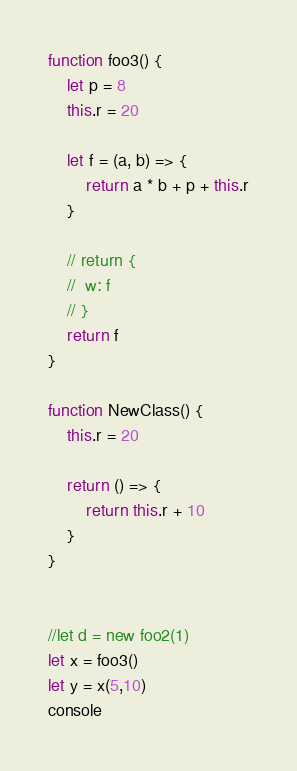<code> <loc_0><loc_0><loc_500><loc_500><_JavaScript_>function foo3() {
	let p = 8
	this.r = 20

	let f = (a, b) => {
		return a * b + p + this.r
	}

	// return {
	// 	w: f
	// }
	return f
}

function NewClass() {
	this.r = 20

	return () => {
		return this.r + 10
    }
}


//let d = new foo2(1)
let x = foo3()
let y = x(5,10)
console
</code> 